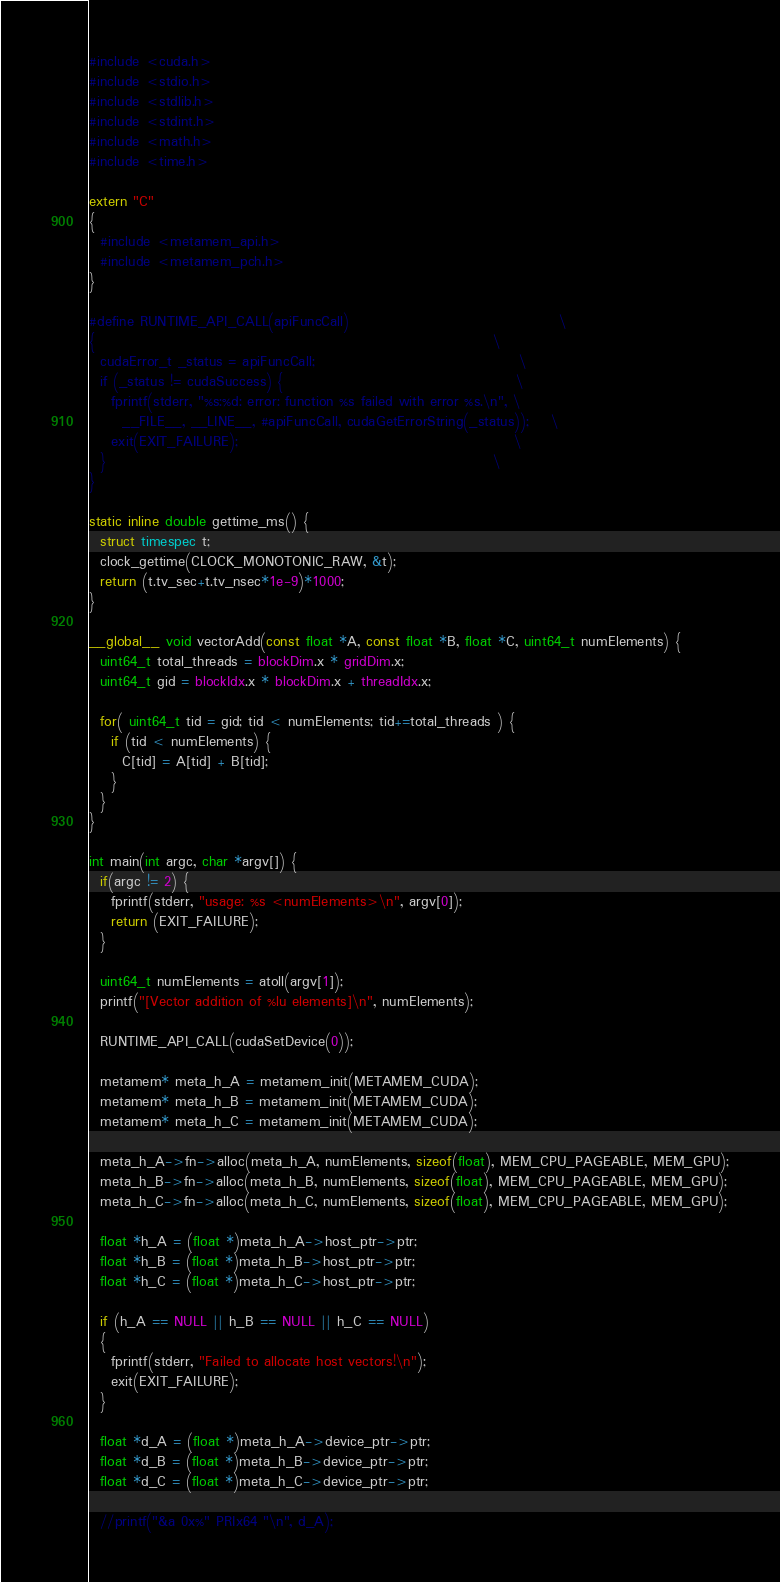<code> <loc_0><loc_0><loc_500><loc_500><_Cuda_>#include <cuda.h>
#include <stdio.h>
#include <stdlib.h>
#include <stdint.h>
#include <math.h>
#include <time.h>

extern "C"
{
  #include <metamem_api.h>
  #include <metamem_pch.h>
}

#define RUNTIME_API_CALL(apiFuncCall)                                      \
{                                                                        \
  cudaError_t _status = apiFuncCall;                                     \
  if (_status != cudaSuccess) {                                          \
    fprintf(stderr, "%s:%d: error: function %s failed with error %s.\n", \
      __FILE__, __LINE__, #apiFuncCall, cudaGetErrorString(_status));    \
    exit(EXIT_FAILURE);                                                  \
  }                                                                      \
}

static inline double gettime_ms() {
  struct timespec t;
  clock_gettime(CLOCK_MONOTONIC_RAW, &t);
  return (t.tv_sec+t.tv_nsec*1e-9)*1000;
}

__global__ void vectorAdd(const float *A, const float *B, float *C, uint64_t numElements) {
  uint64_t total_threads = blockDim.x * gridDim.x;
  uint64_t gid = blockIdx.x * blockDim.x + threadIdx.x;

  for( uint64_t tid = gid; tid < numElements; tid+=total_threads ) {
    if (tid < numElements) {
      C[tid] = A[tid] + B[tid];
    }
  }
}

int main(int argc, char *argv[]) {
  if(argc != 2) {
    fprintf(stderr, "usage: %s <numElements>\n", argv[0]);
    return (EXIT_FAILURE);
  }

  uint64_t numElements = atoll(argv[1]);
  printf("[Vector addition of %lu elements]\n", numElements);

  RUNTIME_API_CALL(cudaSetDevice(0));

  metamem* meta_h_A = metamem_init(METAMEM_CUDA);
  metamem* meta_h_B = metamem_init(METAMEM_CUDA);
  metamem* meta_h_C = metamem_init(METAMEM_CUDA);

  meta_h_A->fn->alloc(meta_h_A, numElements, sizeof(float), MEM_CPU_PAGEABLE, MEM_GPU);
  meta_h_B->fn->alloc(meta_h_B, numElements, sizeof(float), MEM_CPU_PAGEABLE, MEM_GPU);
  meta_h_C->fn->alloc(meta_h_C, numElements, sizeof(float), MEM_CPU_PAGEABLE, MEM_GPU);

  float *h_A = (float *)meta_h_A->host_ptr->ptr;
  float *h_B = (float *)meta_h_B->host_ptr->ptr;
  float *h_C = (float *)meta_h_C->host_ptr->ptr;

  if (h_A == NULL || h_B == NULL || h_C == NULL)
  {
    fprintf(stderr, "Failed to allocate host vectors!\n");
    exit(EXIT_FAILURE);
  }

  float *d_A = (float *)meta_h_A->device_ptr->ptr;
  float *d_B = (float *)meta_h_B->device_ptr->ptr;
  float *d_C = (float *)meta_h_C->device_ptr->ptr;

  //printf("&a 0x%" PRIx64 "\n", d_A);</code> 